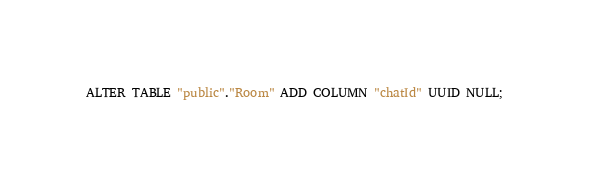<code> <loc_0><loc_0><loc_500><loc_500><_SQL_>ALTER TABLE "public"."Room" ADD COLUMN "chatId" UUID NULL;
</code> 